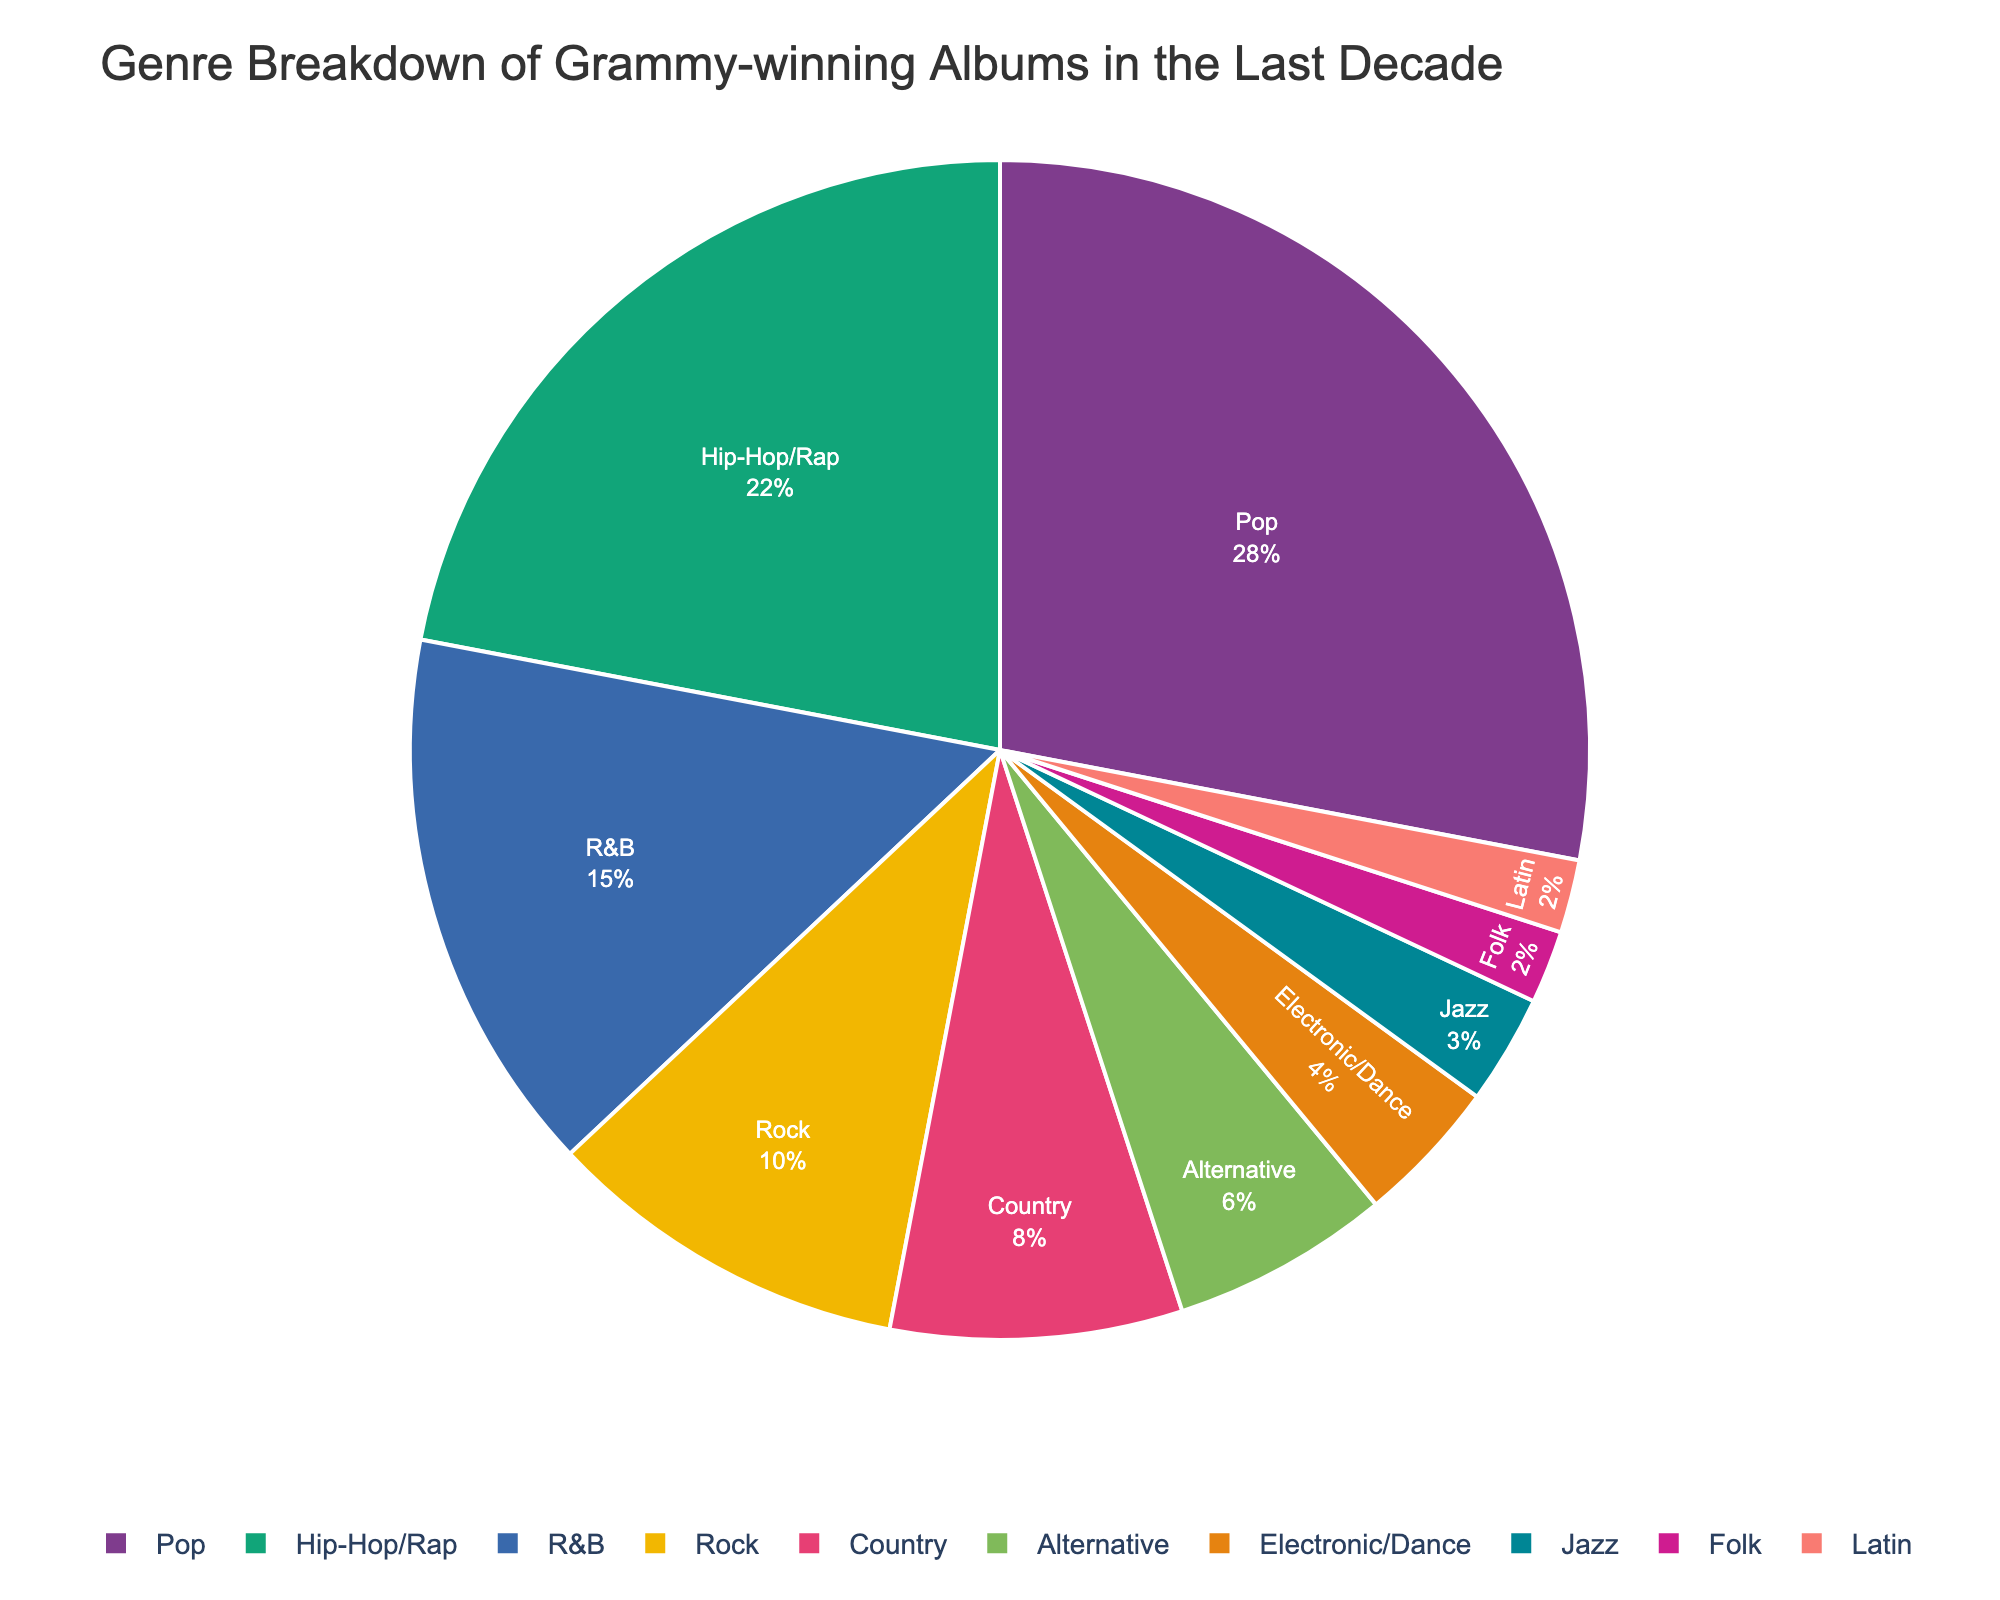Which genre has the highest percentage of Grammy-winning albums? The pie chart shows segments labeled with percentages. The segment labeled "Pop" has the highest percentage at 28%.
Answer: Pop Which genre has the lowest percentage of Grammy-winning albums? The pie chart shows segments labeled with percentages. The segments labeled "Folk" and "Latin" both have the lowest percentage at 2%.
Answer: Folk, Latin How much greater is the percentage of Pop albums compared to Rock albums? The Pop segment is labeled 28% and the Rock segment is labeled 10%. The difference is 28% - 10% = 18%.
Answer: 18% What percentage of Grammy-winning albums are in genres outside of Pop and Hip-Hop/Rap combined? Pop and Hip-Hop/Rap combined account for 28% + 22% = 50%. Therefore, the remaining percentage is 100% - 50% = 50%.
Answer: 50% If you combine the percentages of R&B, Country, and Alternative together, what is their total? R&B, Country, and Alternative are labeled 15%, 8%, and 6%, respectively. Their total is 15% + 8% + 6% = 29%.
Answer: 29% What is the percentage difference between Hip-Hop/Rap and Country albums? Hip-Hop/Rap is labeled 22% while Country is labeled 8%. The percentage difference is 22% - 8% = 14%.
Answer: 14% Which genre has a larger percentage: Alternative or Electronic/Dance? The pie chart shows that Alternative is labeled 6% and Electronic/Dance is labeled 4%. Therefore, Alternative has a larger percentage.
Answer: Alternative What is the sum of the percentages for Rock, Jazz, and Latin albums? Rock, Jazz, and Latin are labeled 10%, 3%, and 2%, respectively. The sum is 10% + 3% + 2% = 15%.
Answer: 15% How does the percentage of Jazz albums compare to that of Folk albums? Jazz is labeled 3%, and Folk is labeled 2%. Therefore, Jazz has a 1% higher percentage than Folk.
Answer: Jazz is 1% higher Of the genres listed, which makes up more than 20% of the Grammy-winning albums? The genres listed above 20% in the pie chart are Pop (28%) and Hip-Hop/Rap (22%).
Answer: Pop, Hip-Hop/Rap 